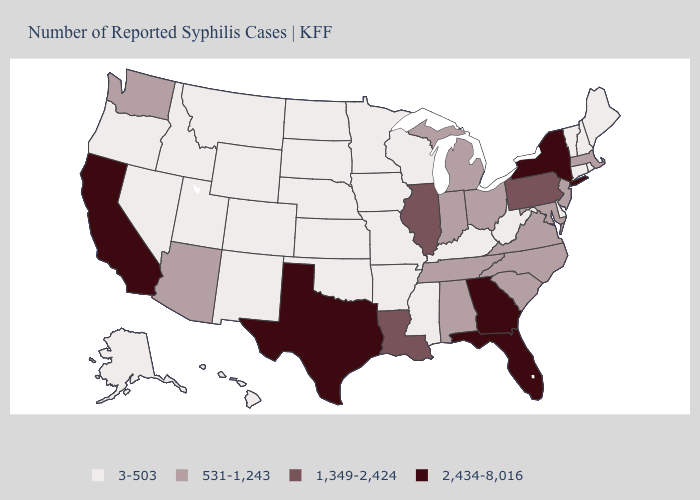Name the states that have a value in the range 2,434-8,016?
Write a very short answer. California, Florida, Georgia, New York, Texas. What is the value of Hawaii?
Write a very short answer. 3-503. Name the states that have a value in the range 531-1,243?
Answer briefly. Alabama, Arizona, Indiana, Maryland, Massachusetts, Michigan, New Jersey, North Carolina, Ohio, South Carolina, Tennessee, Virginia, Washington. Name the states that have a value in the range 531-1,243?
Concise answer only. Alabama, Arizona, Indiana, Maryland, Massachusetts, Michigan, New Jersey, North Carolina, Ohio, South Carolina, Tennessee, Virginia, Washington. What is the highest value in the USA?
Short answer required. 2,434-8,016. Name the states that have a value in the range 531-1,243?
Give a very brief answer. Alabama, Arizona, Indiana, Maryland, Massachusetts, Michigan, New Jersey, North Carolina, Ohio, South Carolina, Tennessee, Virginia, Washington. Among the states that border Tennessee , does Arkansas have the highest value?
Keep it brief. No. What is the value of Utah?
Keep it brief. 3-503. Does Alabama have the highest value in the USA?
Answer briefly. No. What is the value of Tennessee?
Concise answer only. 531-1,243. Name the states that have a value in the range 1,349-2,424?
Answer briefly. Illinois, Louisiana, Pennsylvania. What is the value of California?
Give a very brief answer. 2,434-8,016. Name the states that have a value in the range 2,434-8,016?
Keep it brief. California, Florida, Georgia, New York, Texas. What is the lowest value in the MidWest?
Concise answer only. 3-503. Among the states that border New Mexico , does Texas have the highest value?
Concise answer only. Yes. 